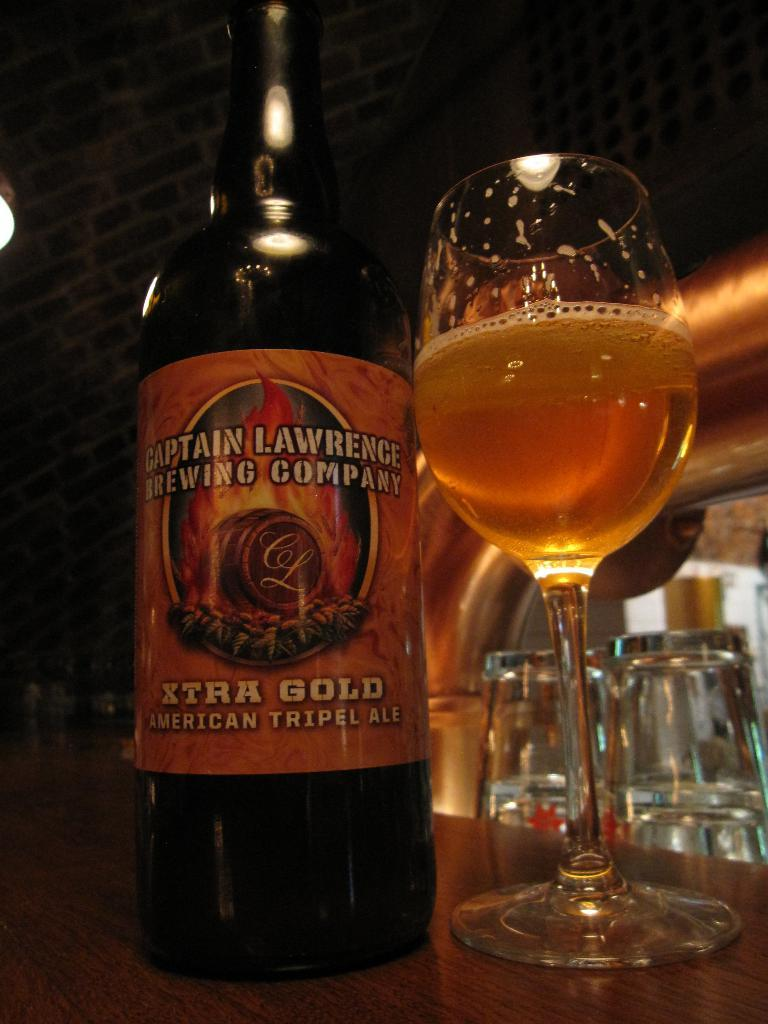<image>
Summarize the visual content of the image. A bottle of Xtra Gold Americal tripel ale sits on a dark wood bar. 